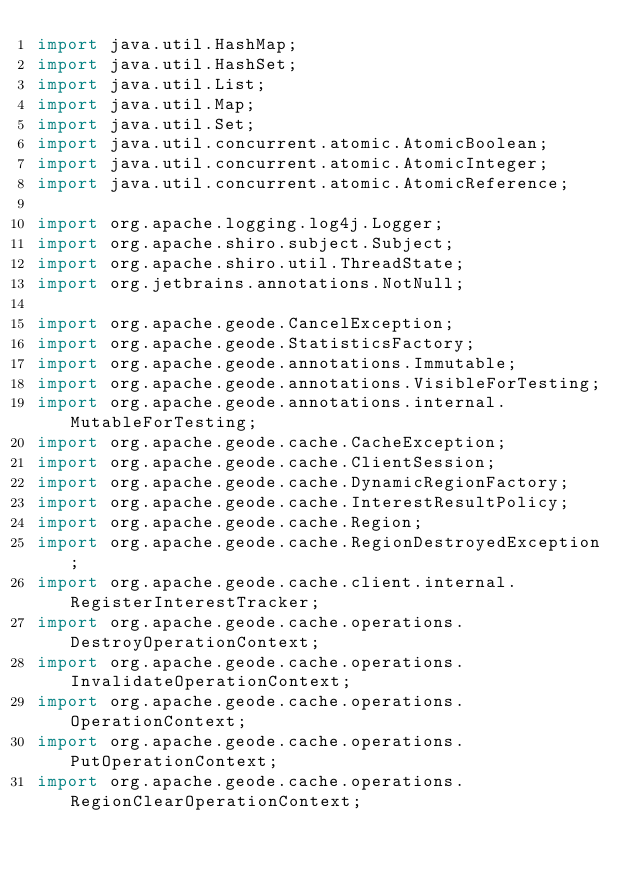<code> <loc_0><loc_0><loc_500><loc_500><_Java_>import java.util.HashMap;
import java.util.HashSet;
import java.util.List;
import java.util.Map;
import java.util.Set;
import java.util.concurrent.atomic.AtomicBoolean;
import java.util.concurrent.atomic.AtomicInteger;
import java.util.concurrent.atomic.AtomicReference;

import org.apache.logging.log4j.Logger;
import org.apache.shiro.subject.Subject;
import org.apache.shiro.util.ThreadState;
import org.jetbrains.annotations.NotNull;

import org.apache.geode.CancelException;
import org.apache.geode.StatisticsFactory;
import org.apache.geode.annotations.Immutable;
import org.apache.geode.annotations.VisibleForTesting;
import org.apache.geode.annotations.internal.MutableForTesting;
import org.apache.geode.cache.CacheException;
import org.apache.geode.cache.ClientSession;
import org.apache.geode.cache.DynamicRegionFactory;
import org.apache.geode.cache.InterestResultPolicy;
import org.apache.geode.cache.Region;
import org.apache.geode.cache.RegionDestroyedException;
import org.apache.geode.cache.client.internal.RegisterInterestTracker;
import org.apache.geode.cache.operations.DestroyOperationContext;
import org.apache.geode.cache.operations.InvalidateOperationContext;
import org.apache.geode.cache.operations.OperationContext;
import org.apache.geode.cache.operations.PutOperationContext;
import org.apache.geode.cache.operations.RegionClearOperationContext;</code> 